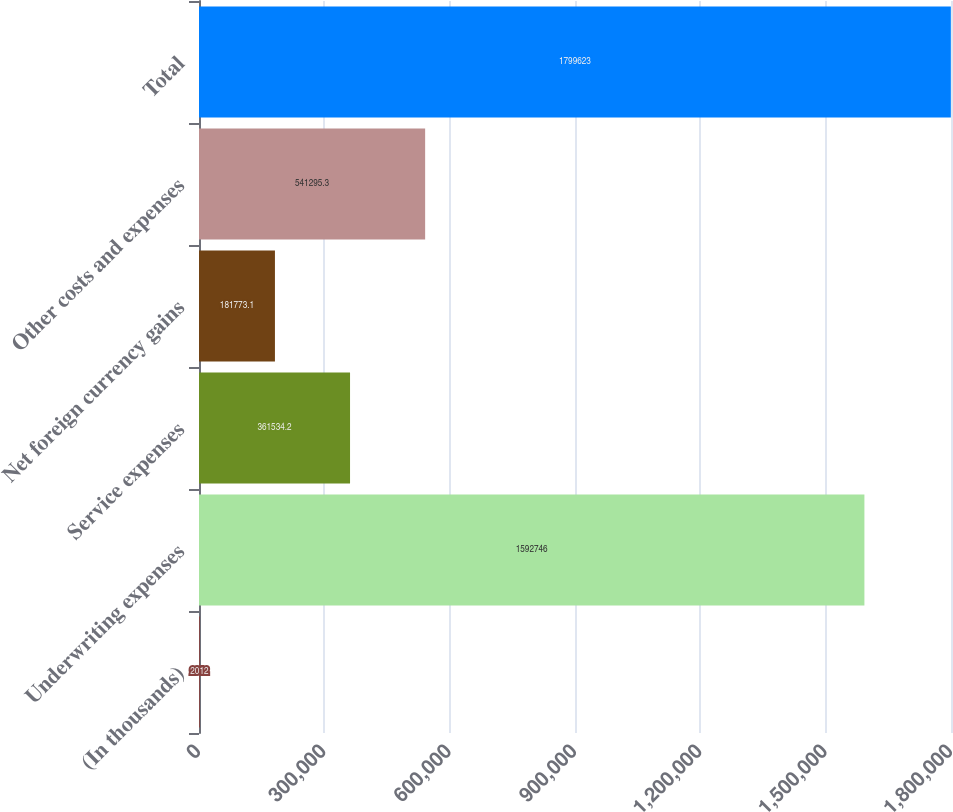Convert chart to OTSL. <chart><loc_0><loc_0><loc_500><loc_500><bar_chart><fcel>(In thousands)<fcel>Underwriting expenses<fcel>Service expenses<fcel>Net foreign currency gains<fcel>Other costs and expenses<fcel>Total<nl><fcel>2012<fcel>1.59275e+06<fcel>361534<fcel>181773<fcel>541295<fcel>1.79962e+06<nl></chart> 